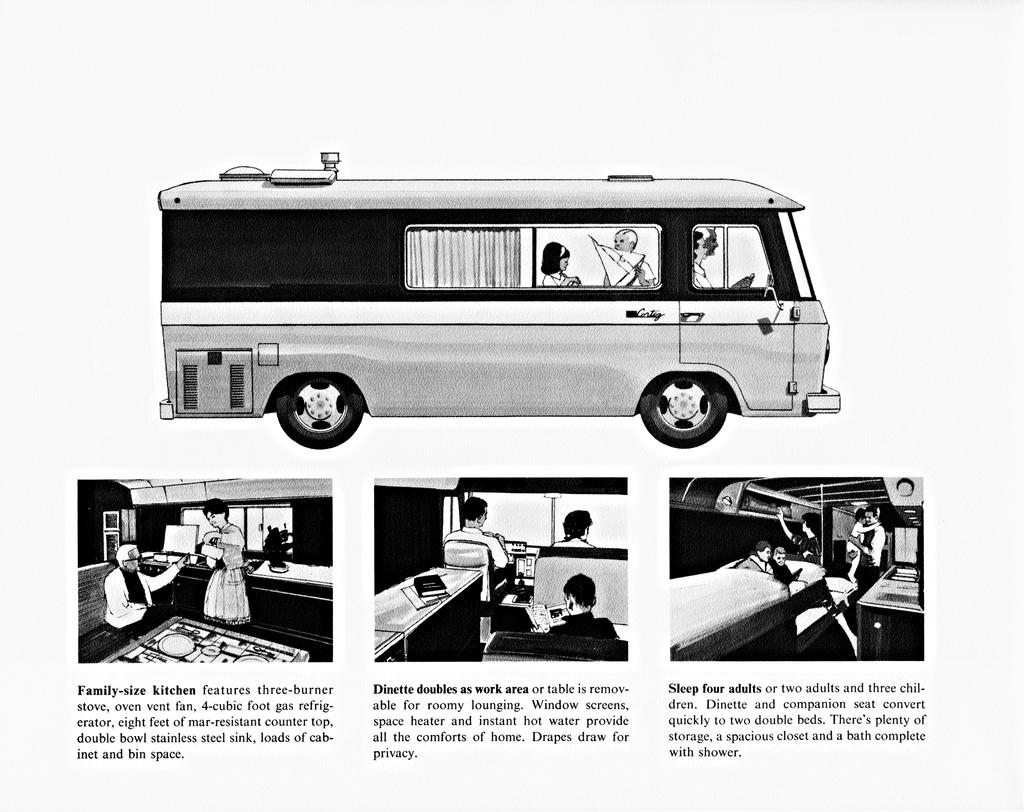<image>
Offer a succinct explanation of the picture presented. the word family size which is under a van 